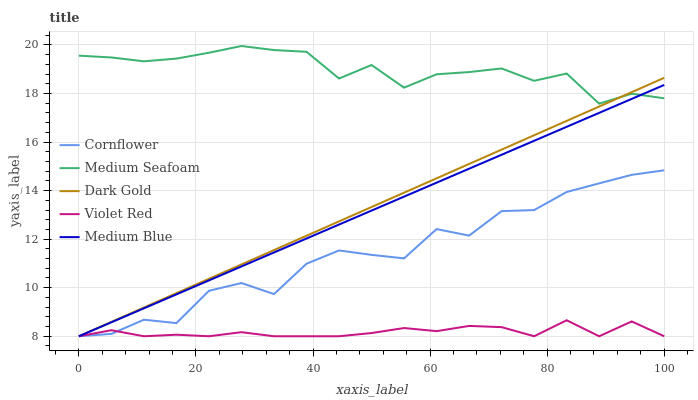Does Violet Red have the minimum area under the curve?
Answer yes or no. Yes. Does Medium Seafoam have the maximum area under the curve?
Answer yes or no. Yes. Does Medium Blue have the minimum area under the curve?
Answer yes or no. No. Does Medium Blue have the maximum area under the curve?
Answer yes or no. No. Is Medium Blue the smoothest?
Answer yes or no. Yes. Is Cornflower the roughest?
Answer yes or no. Yes. Is Violet Red the smoothest?
Answer yes or no. No. Is Violet Red the roughest?
Answer yes or no. No. Does Cornflower have the lowest value?
Answer yes or no. Yes. Does Medium Seafoam have the lowest value?
Answer yes or no. No. Does Medium Seafoam have the highest value?
Answer yes or no. Yes. Does Medium Blue have the highest value?
Answer yes or no. No. Is Violet Red less than Medium Seafoam?
Answer yes or no. Yes. Is Medium Seafoam greater than Violet Red?
Answer yes or no. Yes. Does Violet Red intersect Dark Gold?
Answer yes or no. Yes. Is Violet Red less than Dark Gold?
Answer yes or no. No. Is Violet Red greater than Dark Gold?
Answer yes or no. No. Does Violet Red intersect Medium Seafoam?
Answer yes or no. No. 